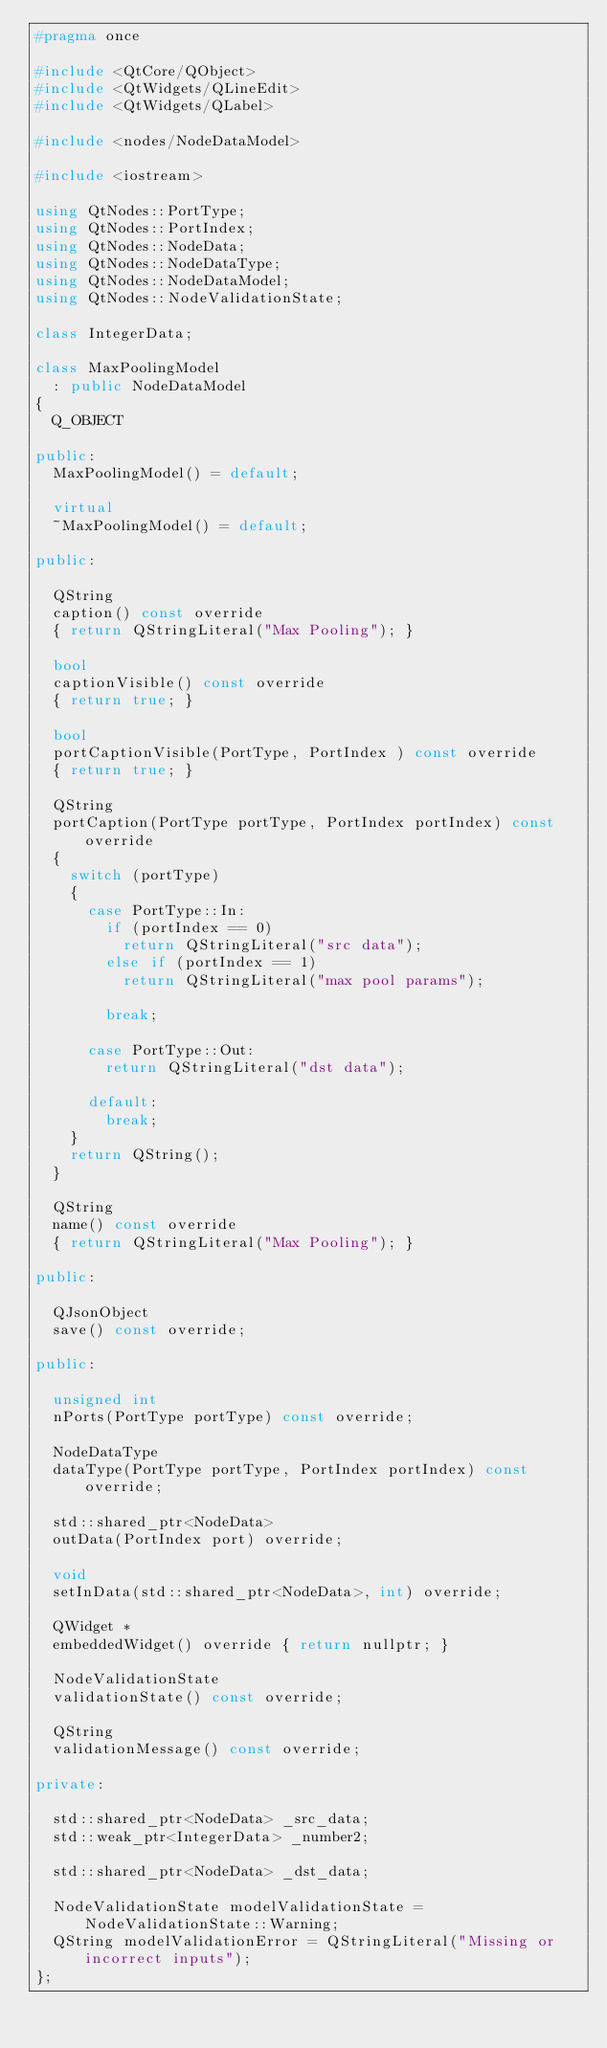<code> <loc_0><loc_0><loc_500><loc_500><_C++_>#pragma once

#include <QtCore/QObject>
#include <QtWidgets/QLineEdit>
#include <QtWidgets/QLabel>

#include <nodes/NodeDataModel>

#include <iostream>

using QtNodes::PortType;
using QtNodes::PortIndex;
using QtNodes::NodeData;
using QtNodes::NodeDataType;
using QtNodes::NodeDataModel;
using QtNodes::NodeValidationState;

class IntegerData;

class MaxPoolingModel
  : public NodeDataModel
{
  Q_OBJECT

public:
  MaxPoolingModel() = default;

  virtual
  ~MaxPoolingModel() = default;

public:

  QString
  caption() const override
  { return QStringLiteral("Max Pooling"); }

  bool
  captionVisible() const override
  { return true; }

  bool
  portCaptionVisible(PortType, PortIndex ) const override
  { return true; }

  QString
  portCaption(PortType portType, PortIndex portIndex) const override
  {
    switch (portType)
    {
      case PortType::In:
        if (portIndex == 0)
          return QStringLiteral("src data");
        else if (portIndex == 1)
          return QStringLiteral("max pool params");

        break;

      case PortType::Out:
        return QStringLiteral("dst data");

      default:
        break;
    }
    return QString();
  }

  QString
  name() const override
  { return QStringLiteral("Max Pooling"); }

public:

  QJsonObject
  save() const override;

public:

  unsigned int
  nPorts(PortType portType) const override;

  NodeDataType
  dataType(PortType portType, PortIndex portIndex) const override;

  std::shared_ptr<NodeData>
  outData(PortIndex port) override;

  void
  setInData(std::shared_ptr<NodeData>, int) override;

  QWidget *
  embeddedWidget() override { return nullptr; }

  NodeValidationState
  validationState() const override;

  QString
  validationMessage() const override;

private:

  std::shared_ptr<NodeData> _src_data;
  std::weak_ptr<IntegerData> _number2;

  std::shared_ptr<NodeData> _dst_data;

  NodeValidationState modelValidationState = NodeValidationState::Warning;
  QString modelValidationError = QStringLiteral("Missing or incorrect inputs");
};
</code> 